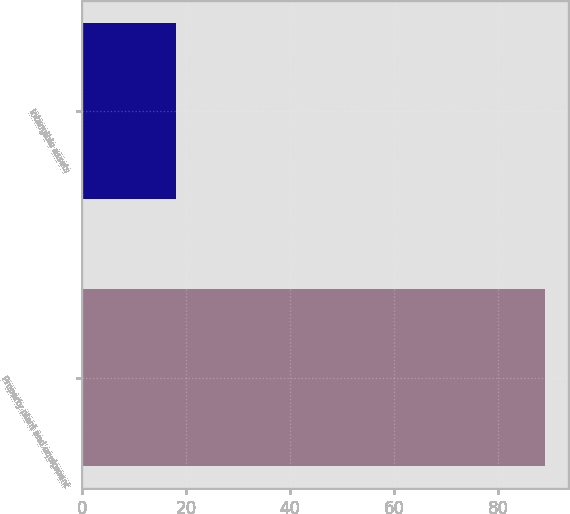Convert chart. <chart><loc_0><loc_0><loc_500><loc_500><bar_chart><fcel>Property plant and equipment<fcel>Intangible assets<nl><fcel>89<fcel>18<nl></chart> 